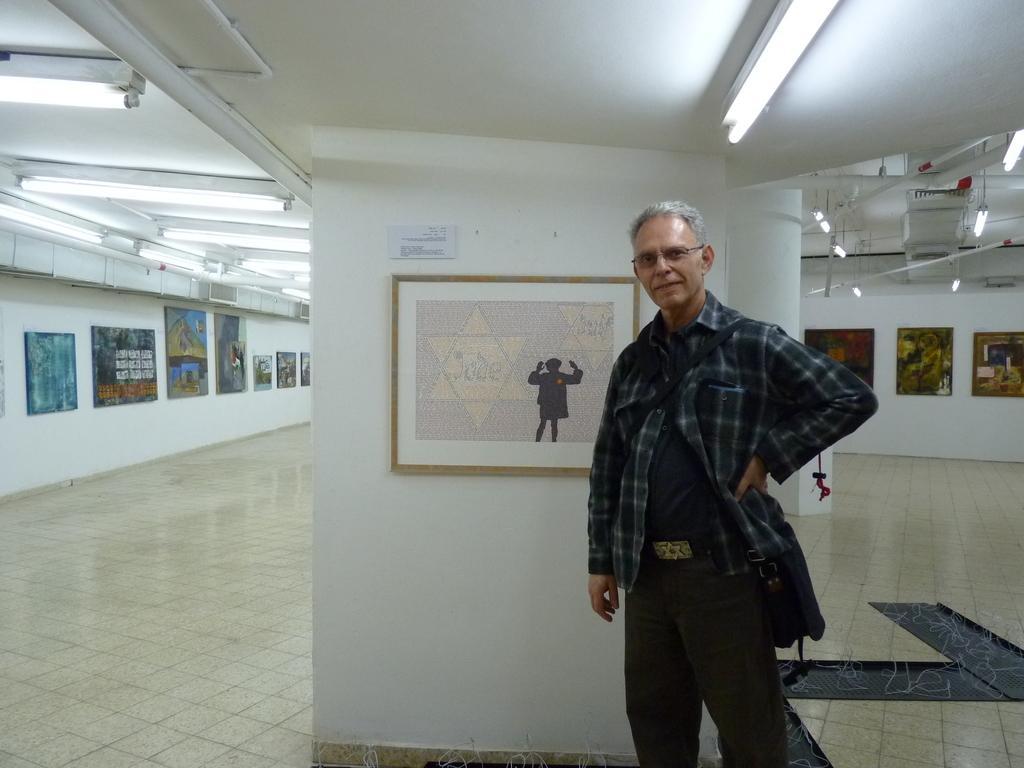Please provide a concise description of this image. In this image I can see the person standing and wearing the black color dress. To the side there is frame to the wall. In the back I can see many frames to the white wall and these frames are colorful. I can also see many lights in the top. 